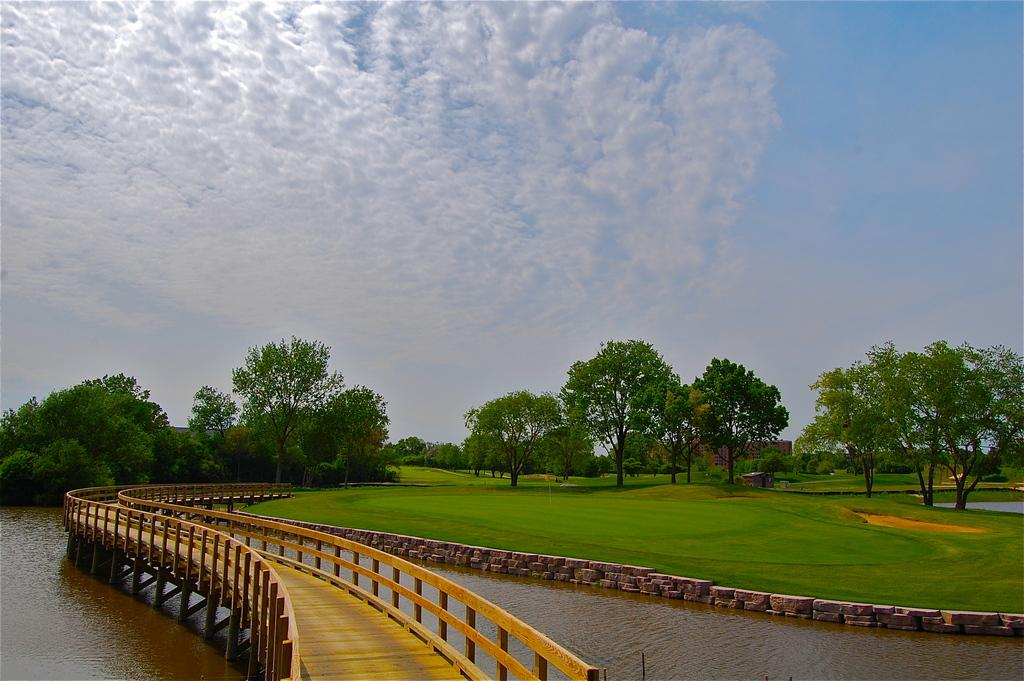What type of structure is present in the image? There is a wooden bridge in the image. What natural elements can be seen in the image? There are trees, grass, and a lake in the image. What type of building is visible in the image? There is a house in the image. What is the condition of the sky in the image? The sky is cloudy in the image. What type of oatmeal is being served on the wooden bridge in the image? There is no oatmeal present in the image; it features a wooden bridge, trees, grass, a house, a lake, and a cloudy sky. What stage of development is the slope in the image? There is no slope mentioned or visible in the image. 